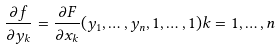<formula> <loc_0><loc_0><loc_500><loc_500>\frac { \partial f } { \partial y _ { k } } = \frac { \partial F } { \partial x _ { k } } ( y _ { 1 } , \dots , y _ { n } , 1 , \dots , 1 ) k = 1 , \dots , n</formula> 